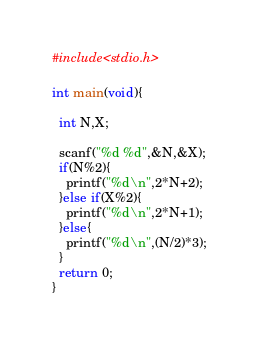<code> <loc_0><loc_0><loc_500><loc_500><_C_>#include<stdio.h>

int main(void){

  int N,X;

  scanf("%d %d",&N,&X);
  if(N%2){
    printf("%d\n",2*N+2);
  }else if(X%2){
    printf("%d\n",2*N+1);
  }else{
    printf("%d\n",(N/2)*3);
  }
  return 0;
}
</code> 